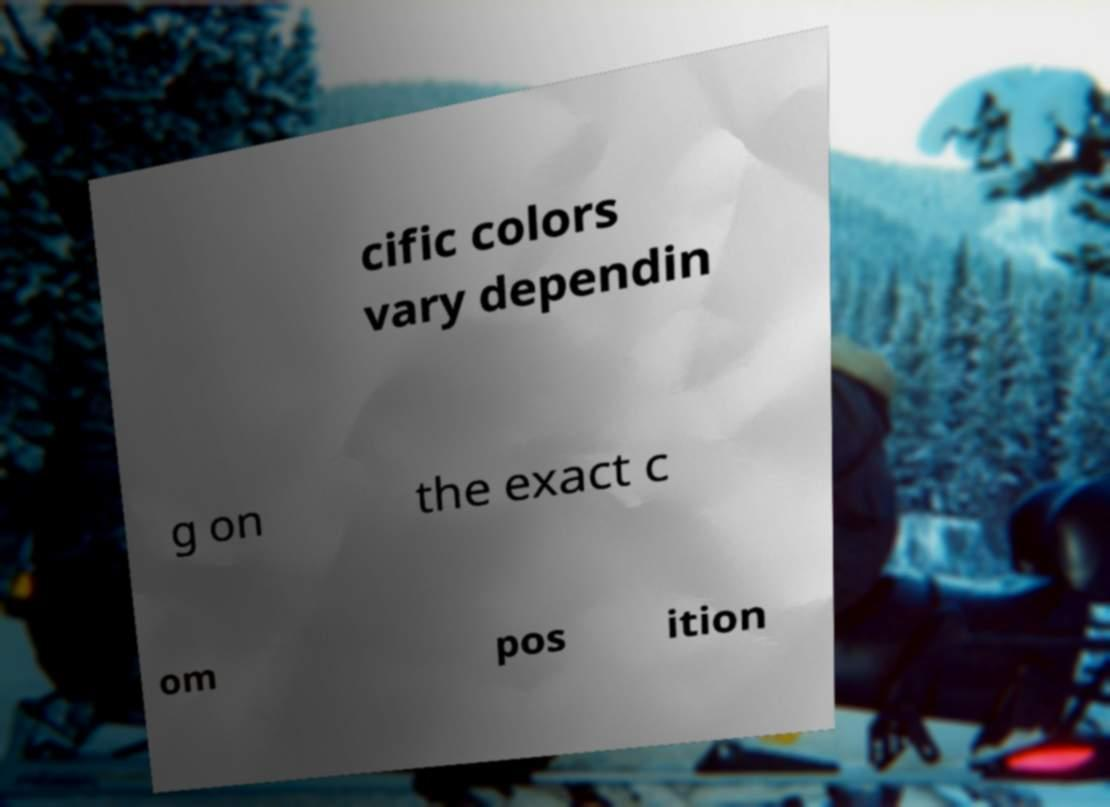For documentation purposes, I need the text within this image transcribed. Could you provide that? cific colors vary dependin g on the exact c om pos ition 